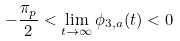<formula> <loc_0><loc_0><loc_500><loc_500>- \frac { \pi _ { p } } 2 < \lim _ { t \to \infty } \phi _ { 3 , a } ( t ) < 0</formula> 